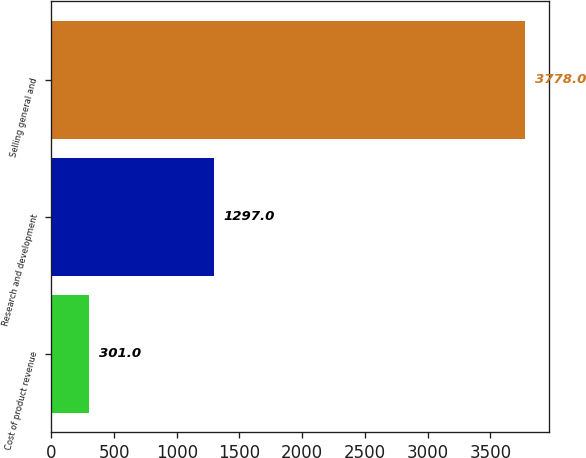Convert chart. <chart><loc_0><loc_0><loc_500><loc_500><bar_chart><fcel>Cost of product revenue<fcel>Research and development<fcel>Selling general and<nl><fcel>301<fcel>1297<fcel>3778<nl></chart> 